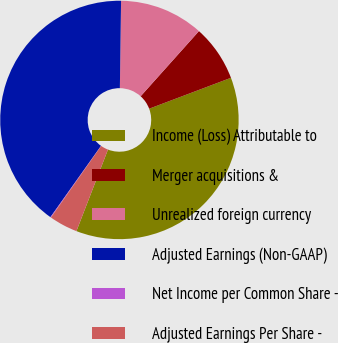<chart> <loc_0><loc_0><loc_500><loc_500><pie_chart><fcel>Income (Loss) Attributable to<fcel>Merger acquisitions &<fcel>Unrealized foreign currency<fcel>Adjusted Earnings (Non-GAAP)<fcel>Net Income per Common Share -<fcel>Adjusted Earnings Per Share -<nl><fcel>36.62%<fcel>7.63%<fcel>11.4%<fcel>40.39%<fcel>0.09%<fcel>3.86%<nl></chart> 